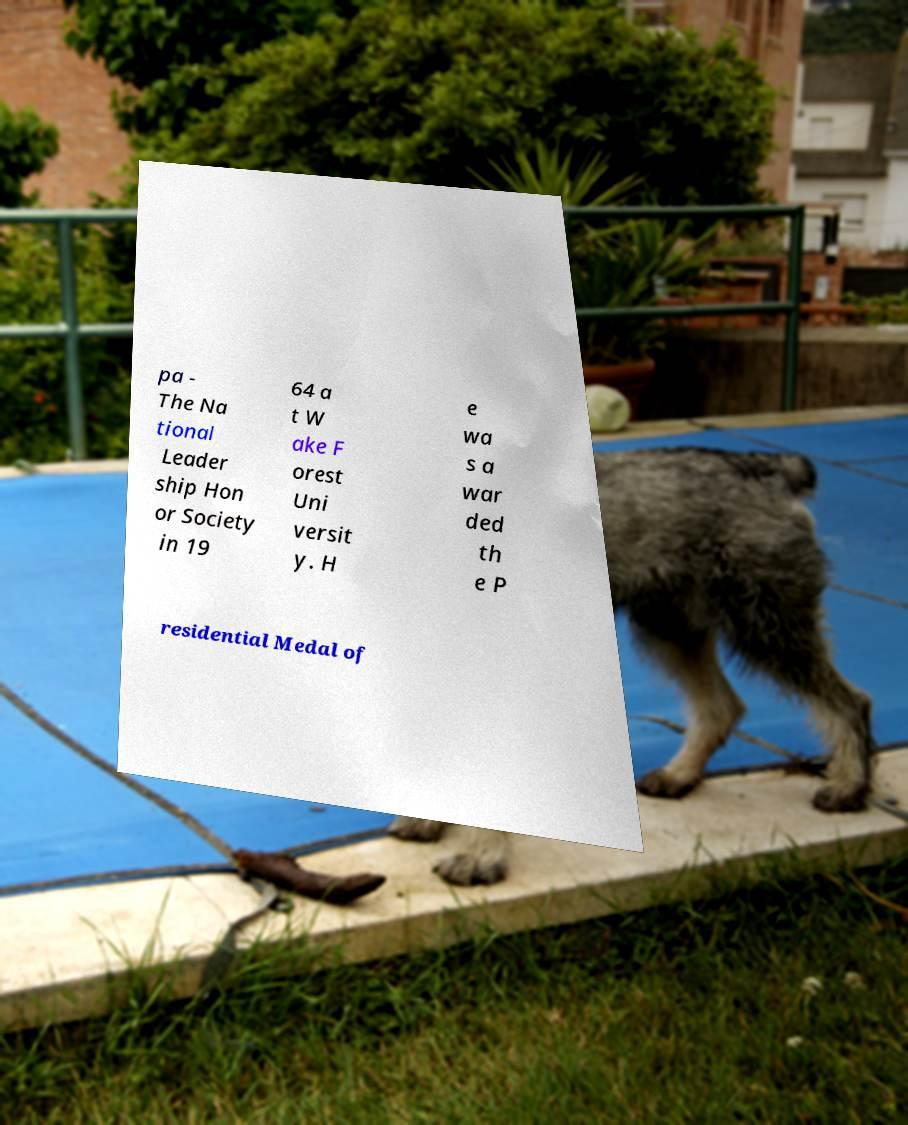I need the written content from this picture converted into text. Can you do that? pa - The Na tional Leader ship Hon or Society in 19 64 a t W ake F orest Uni versit y. H e wa s a war ded th e P residential Medal of 